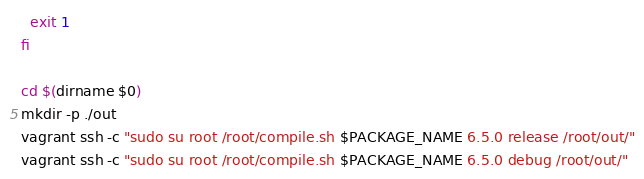Convert code to text. <code><loc_0><loc_0><loc_500><loc_500><_Bash_>  exit 1
fi

cd $(dirname $0)
mkdir -p ./out
vagrant ssh -c "sudo su root /root/compile.sh $PACKAGE_NAME 6.5.0 release /root/out/"
vagrant ssh -c "sudo su root /root/compile.sh $PACKAGE_NAME 6.5.0 debug /root/out/"
</code> 